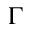<formula> <loc_0><loc_0><loc_500><loc_500>\Gamma</formula> 